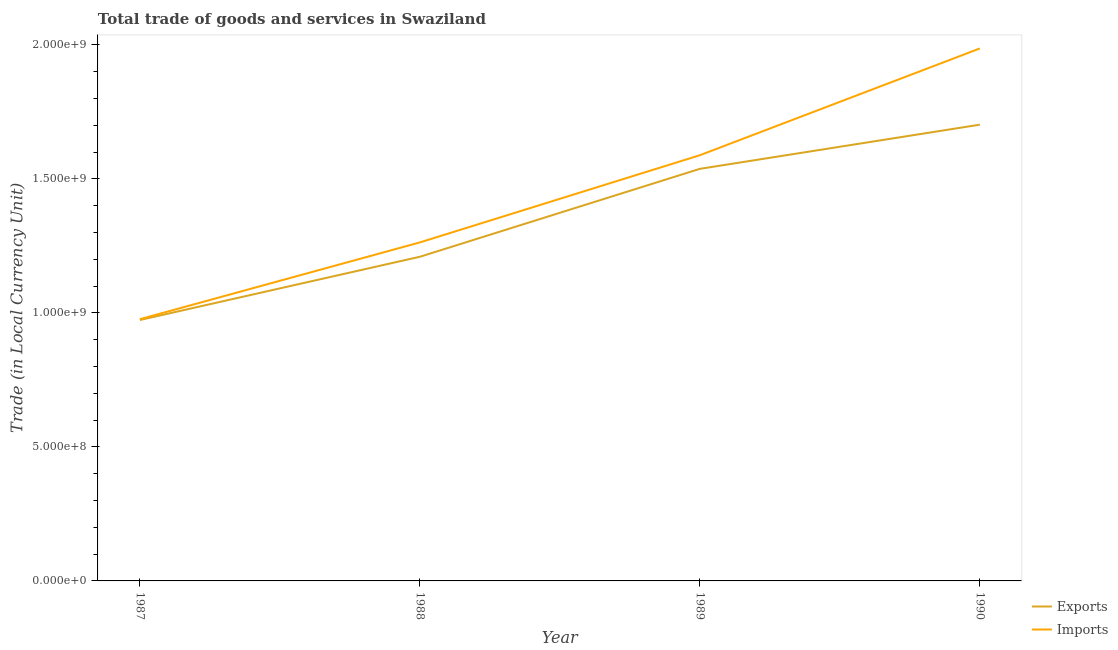How many different coloured lines are there?
Give a very brief answer. 2. Does the line corresponding to imports of goods and services intersect with the line corresponding to export of goods and services?
Give a very brief answer. No. Is the number of lines equal to the number of legend labels?
Give a very brief answer. Yes. What is the imports of goods and services in 1987?
Make the answer very short. 9.76e+08. Across all years, what is the maximum export of goods and services?
Ensure brevity in your answer.  1.70e+09. Across all years, what is the minimum export of goods and services?
Keep it short and to the point. 9.73e+08. In which year was the export of goods and services maximum?
Provide a succinct answer. 1990. What is the total imports of goods and services in the graph?
Your answer should be very brief. 5.81e+09. What is the difference between the imports of goods and services in 1988 and that in 1990?
Your answer should be very brief. -7.24e+08. What is the difference between the export of goods and services in 1987 and the imports of goods and services in 1990?
Your answer should be very brief. -1.01e+09. What is the average imports of goods and services per year?
Provide a short and direct response. 1.45e+09. In the year 1989, what is the difference between the imports of goods and services and export of goods and services?
Your response must be concise. 5.08e+07. What is the ratio of the imports of goods and services in 1989 to that in 1990?
Offer a terse response. 0.8. What is the difference between the highest and the second highest imports of goods and services?
Your answer should be very brief. 3.98e+08. What is the difference between the highest and the lowest export of goods and services?
Your response must be concise. 7.29e+08. In how many years, is the imports of goods and services greater than the average imports of goods and services taken over all years?
Give a very brief answer. 2. Does the export of goods and services monotonically increase over the years?
Give a very brief answer. Yes. Is the imports of goods and services strictly less than the export of goods and services over the years?
Offer a very short reply. No. How many lines are there?
Make the answer very short. 2. Are the values on the major ticks of Y-axis written in scientific E-notation?
Offer a terse response. Yes. Does the graph contain any zero values?
Keep it short and to the point. No. Does the graph contain grids?
Provide a succinct answer. No. What is the title of the graph?
Provide a succinct answer. Total trade of goods and services in Swaziland. What is the label or title of the X-axis?
Provide a succinct answer. Year. What is the label or title of the Y-axis?
Provide a short and direct response. Trade (in Local Currency Unit). What is the Trade (in Local Currency Unit) in Exports in 1987?
Offer a terse response. 9.73e+08. What is the Trade (in Local Currency Unit) in Imports in 1987?
Provide a succinct answer. 9.76e+08. What is the Trade (in Local Currency Unit) in Exports in 1988?
Your response must be concise. 1.21e+09. What is the Trade (in Local Currency Unit) in Imports in 1988?
Provide a succinct answer. 1.26e+09. What is the Trade (in Local Currency Unit) of Exports in 1989?
Your answer should be very brief. 1.54e+09. What is the Trade (in Local Currency Unit) in Imports in 1989?
Your response must be concise. 1.59e+09. What is the Trade (in Local Currency Unit) in Exports in 1990?
Provide a succinct answer. 1.70e+09. What is the Trade (in Local Currency Unit) of Imports in 1990?
Your answer should be compact. 1.99e+09. Across all years, what is the maximum Trade (in Local Currency Unit) of Exports?
Your answer should be compact. 1.70e+09. Across all years, what is the maximum Trade (in Local Currency Unit) of Imports?
Offer a very short reply. 1.99e+09. Across all years, what is the minimum Trade (in Local Currency Unit) in Exports?
Provide a short and direct response. 9.73e+08. Across all years, what is the minimum Trade (in Local Currency Unit) in Imports?
Offer a terse response. 9.76e+08. What is the total Trade (in Local Currency Unit) in Exports in the graph?
Ensure brevity in your answer.  5.42e+09. What is the total Trade (in Local Currency Unit) of Imports in the graph?
Offer a very short reply. 5.81e+09. What is the difference between the Trade (in Local Currency Unit) in Exports in 1987 and that in 1988?
Provide a succinct answer. -2.36e+08. What is the difference between the Trade (in Local Currency Unit) in Imports in 1987 and that in 1988?
Keep it short and to the point. -2.86e+08. What is the difference between the Trade (in Local Currency Unit) in Exports in 1987 and that in 1989?
Your answer should be compact. -5.64e+08. What is the difference between the Trade (in Local Currency Unit) of Imports in 1987 and that in 1989?
Offer a terse response. -6.12e+08. What is the difference between the Trade (in Local Currency Unit) in Exports in 1987 and that in 1990?
Your answer should be very brief. -7.29e+08. What is the difference between the Trade (in Local Currency Unit) in Imports in 1987 and that in 1990?
Offer a terse response. -1.01e+09. What is the difference between the Trade (in Local Currency Unit) of Exports in 1988 and that in 1989?
Offer a very short reply. -3.28e+08. What is the difference between the Trade (in Local Currency Unit) in Imports in 1988 and that in 1989?
Your response must be concise. -3.25e+08. What is the difference between the Trade (in Local Currency Unit) in Exports in 1988 and that in 1990?
Your answer should be very brief. -4.93e+08. What is the difference between the Trade (in Local Currency Unit) of Imports in 1988 and that in 1990?
Your answer should be very brief. -7.24e+08. What is the difference between the Trade (in Local Currency Unit) in Exports in 1989 and that in 1990?
Keep it short and to the point. -1.65e+08. What is the difference between the Trade (in Local Currency Unit) in Imports in 1989 and that in 1990?
Ensure brevity in your answer.  -3.98e+08. What is the difference between the Trade (in Local Currency Unit) in Exports in 1987 and the Trade (in Local Currency Unit) in Imports in 1988?
Your answer should be compact. -2.90e+08. What is the difference between the Trade (in Local Currency Unit) in Exports in 1987 and the Trade (in Local Currency Unit) in Imports in 1989?
Keep it short and to the point. -6.15e+08. What is the difference between the Trade (in Local Currency Unit) in Exports in 1987 and the Trade (in Local Currency Unit) in Imports in 1990?
Your answer should be compact. -1.01e+09. What is the difference between the Trade (in Local Currency Unit) of Exports in 1988 and the Trade (in Local Currency Unit) of Imports in 1989?
Keep it short and to the point. -3.79e+08. What is the difference between the Trade (in Local Currency Unit) of Exports in 1988 and the Trade (in Local Currency Unit) of Imports in 1990?
Offer a very short reply. -7.77e+08. What is the difference between the Trade (in Local Currency Unit) in Exports in 1989 and the Trade (in Local Currency Unit) in Imports in 1990?
Offer a very short reply. -4.49e+08. What is the average Trade (in Local Currency Unit) of Exports per year?
Give a very brief answer. 1.36e+09. What is the average Trade (in Local Currency Unit) of Imports per year?
Offer a terse response. 1.45e+09. In the year 1987, what is the difference between the Trade (in Local Currency Unit) of Exports and Trade (in Local Currency Unit) of Imports?
Offer a terse response. -3.10e+06. In the year 1988, what is the difference between the Trade (in Local Currency Unit) in Exports and Trade (in Local Currency Unit) in Imports?
Keep it short and to the point. -5.35e+07. In the year 1989, what is the difference between the Trade (in Local Currency Unit) in Exports and Trade (in Local Currency Unit) in Imports?
Provide a short and direct response. -5.08e+07. In the year 1990, what is the difference between the Trade (in Local Currency Unit) in Exports and Trade (in Local Currency Unit) in Imports?
Give a very brief answer. -2.84e+08. What is the ratio of the Trade (in Local Currency Unit) of Exports in 1987 to that in 1988?
Your answer should be very brief. 0.8. What is the ratio of the Trade (in Local Currency Unit) in Imports in 1987 to that in 1988?
Ensure brevity in your answer.  0.77. What is the ratio of the Trade (in Local Currency Unit) in Exports in 1987 to that in 1989?
Offer a very short reply. 0.63. What is the ratio of the Trade (in Local Currency Unit) of Imports in 1987 to that in 1989?
Make the answer very short. 0.61. What is the ratio of the Trade (in Local Currency Unit) of Exports in 1987 to that in 1990?
Offer a terse response. 0.57. What is the ratio of the Trade (in Local Currency Unit) of Imports in 1987 to that in 1990?
Offer a very short reply. 0.49. What is the ratio of the Trade (in Local Currency Unit) in Exports in 1988 to that in 1989?
Provide a succinct answer. 0.79. What is the ratio of the Trade (in Local Currency Unit) of Imports in 1988 to that in 1989?
Offer a very short reply. 0.8. What is the ratio of the Trade (in Local Currency Unit) in Exports in 1988 to that in 1990?
Keep it short and to the point. 0.71. What is the ratio of the Trade (in Local Currency Unit) in Imports in 1988 to that in 1990?
Offer a terse response. 0.64. What is the ratio of the Trade (in Local Currency Unit) of Exports in 1989 to that in 1990?
Ensure brevity in your answer.  0.9. What is the ratio of the Trade (in Local Currency Unit) of Imports in 1989 to that in 1990?
Give a very brief answer. 0.8. What is the difference between the highest and the second highest Trade (in Local Currency Unit) in Exports?
Keep it short and to the point. 1.65e+08. What is the difference between the highest and the second highest Trade (in Local Currency Unit) in Imports?
Your response must be concise. 3.98e+08. What is the difference between the highest and the lowest Trade (in Local Currency Unit) in Exports?
Offer a terse response. 7.29e+08. What is the difference between the highest and the lowest Trade (in Local Currency Unit) in Imports?
Offer a very short reply. 1.01e+09. 